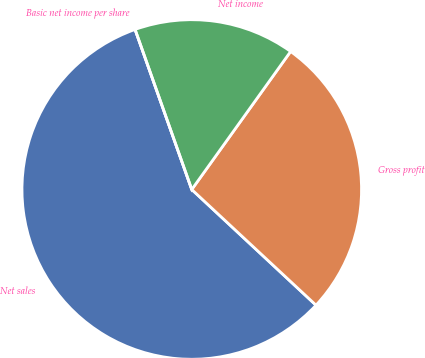Convert chart. <chart><loc_0><loc_0><loc_500><loc_500><pie_chart><fcel>Net sales<fcel>Gross profit<fcel>Net income<fcel>Basic net income per share<nl><fcel>57.65%<fcel>27.04%<fcel>15.31%<fcel>0.0%<nl></chart> 